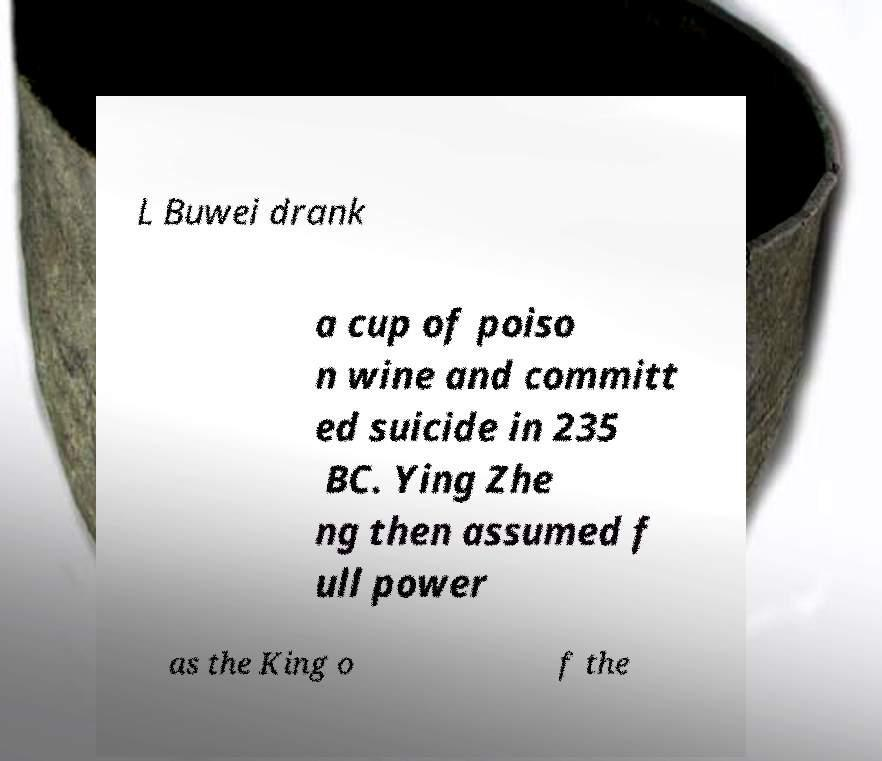For documentation purposes, I need the text within this image transcribed. Could you provide that? L Buwei drank a cup of poiso n wine and committ ed suicide in 235 BC. Ying Zhe ng then assumed f ull power as the King o f the 